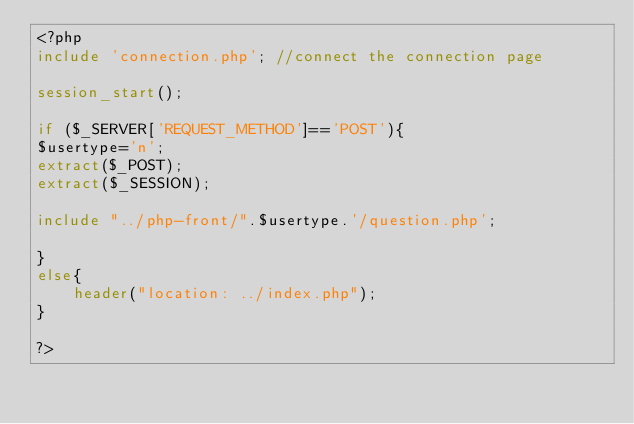Convert code to text. <code><loc_0><loc_0><loc_500><loc_500><_PHP_><?php
include 'connection.php'; //connect the connection page
  
session_start();

if ($_SERVER['REQUEST_METHOD']=='POST'){
$usertype='n';
extract($_POST);
extract($_SESSION);

include "../php-front/".$usertype.'/question.php';

}
else{
	header("location: ../index.php");
}

?></code> 